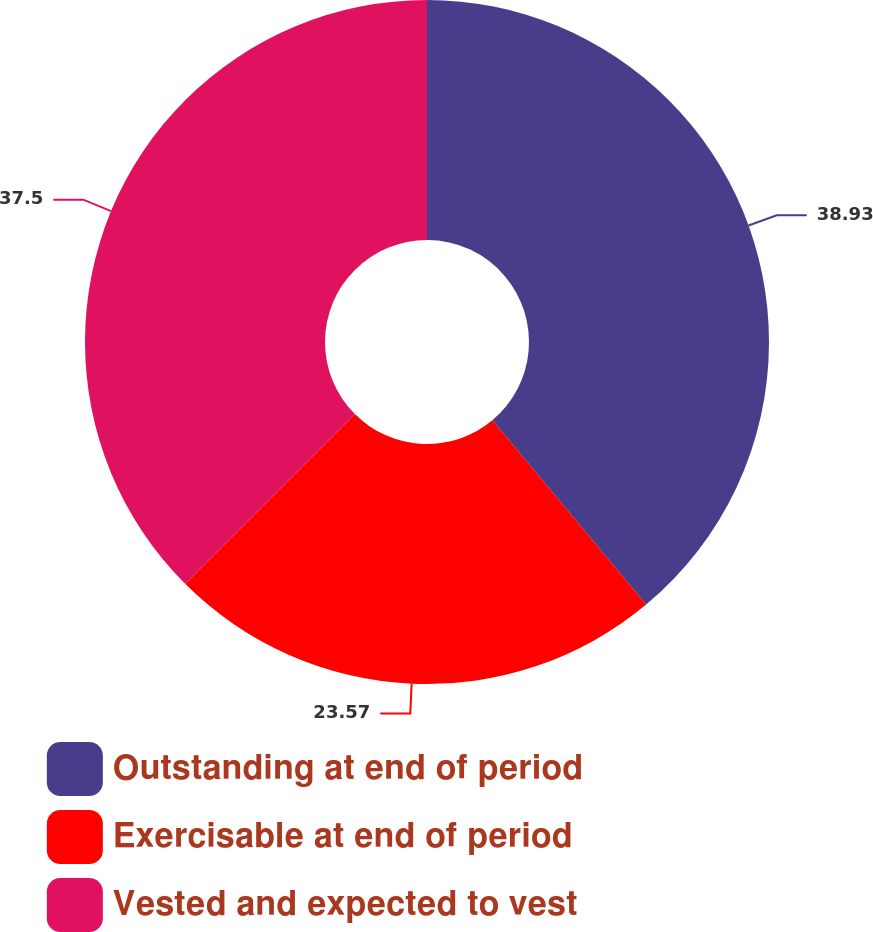Convert chart to OTSL. <chart><loc_0><loc_0><loc_500><loc_500><pie_chart><fcel>Outstanding at end of period<fcel>Exercisable at end of period<fcel>Vested and expected to vest<nl><fcel>38.93%<fcel>23.57%<fcel>37.5%<nl></chart> 